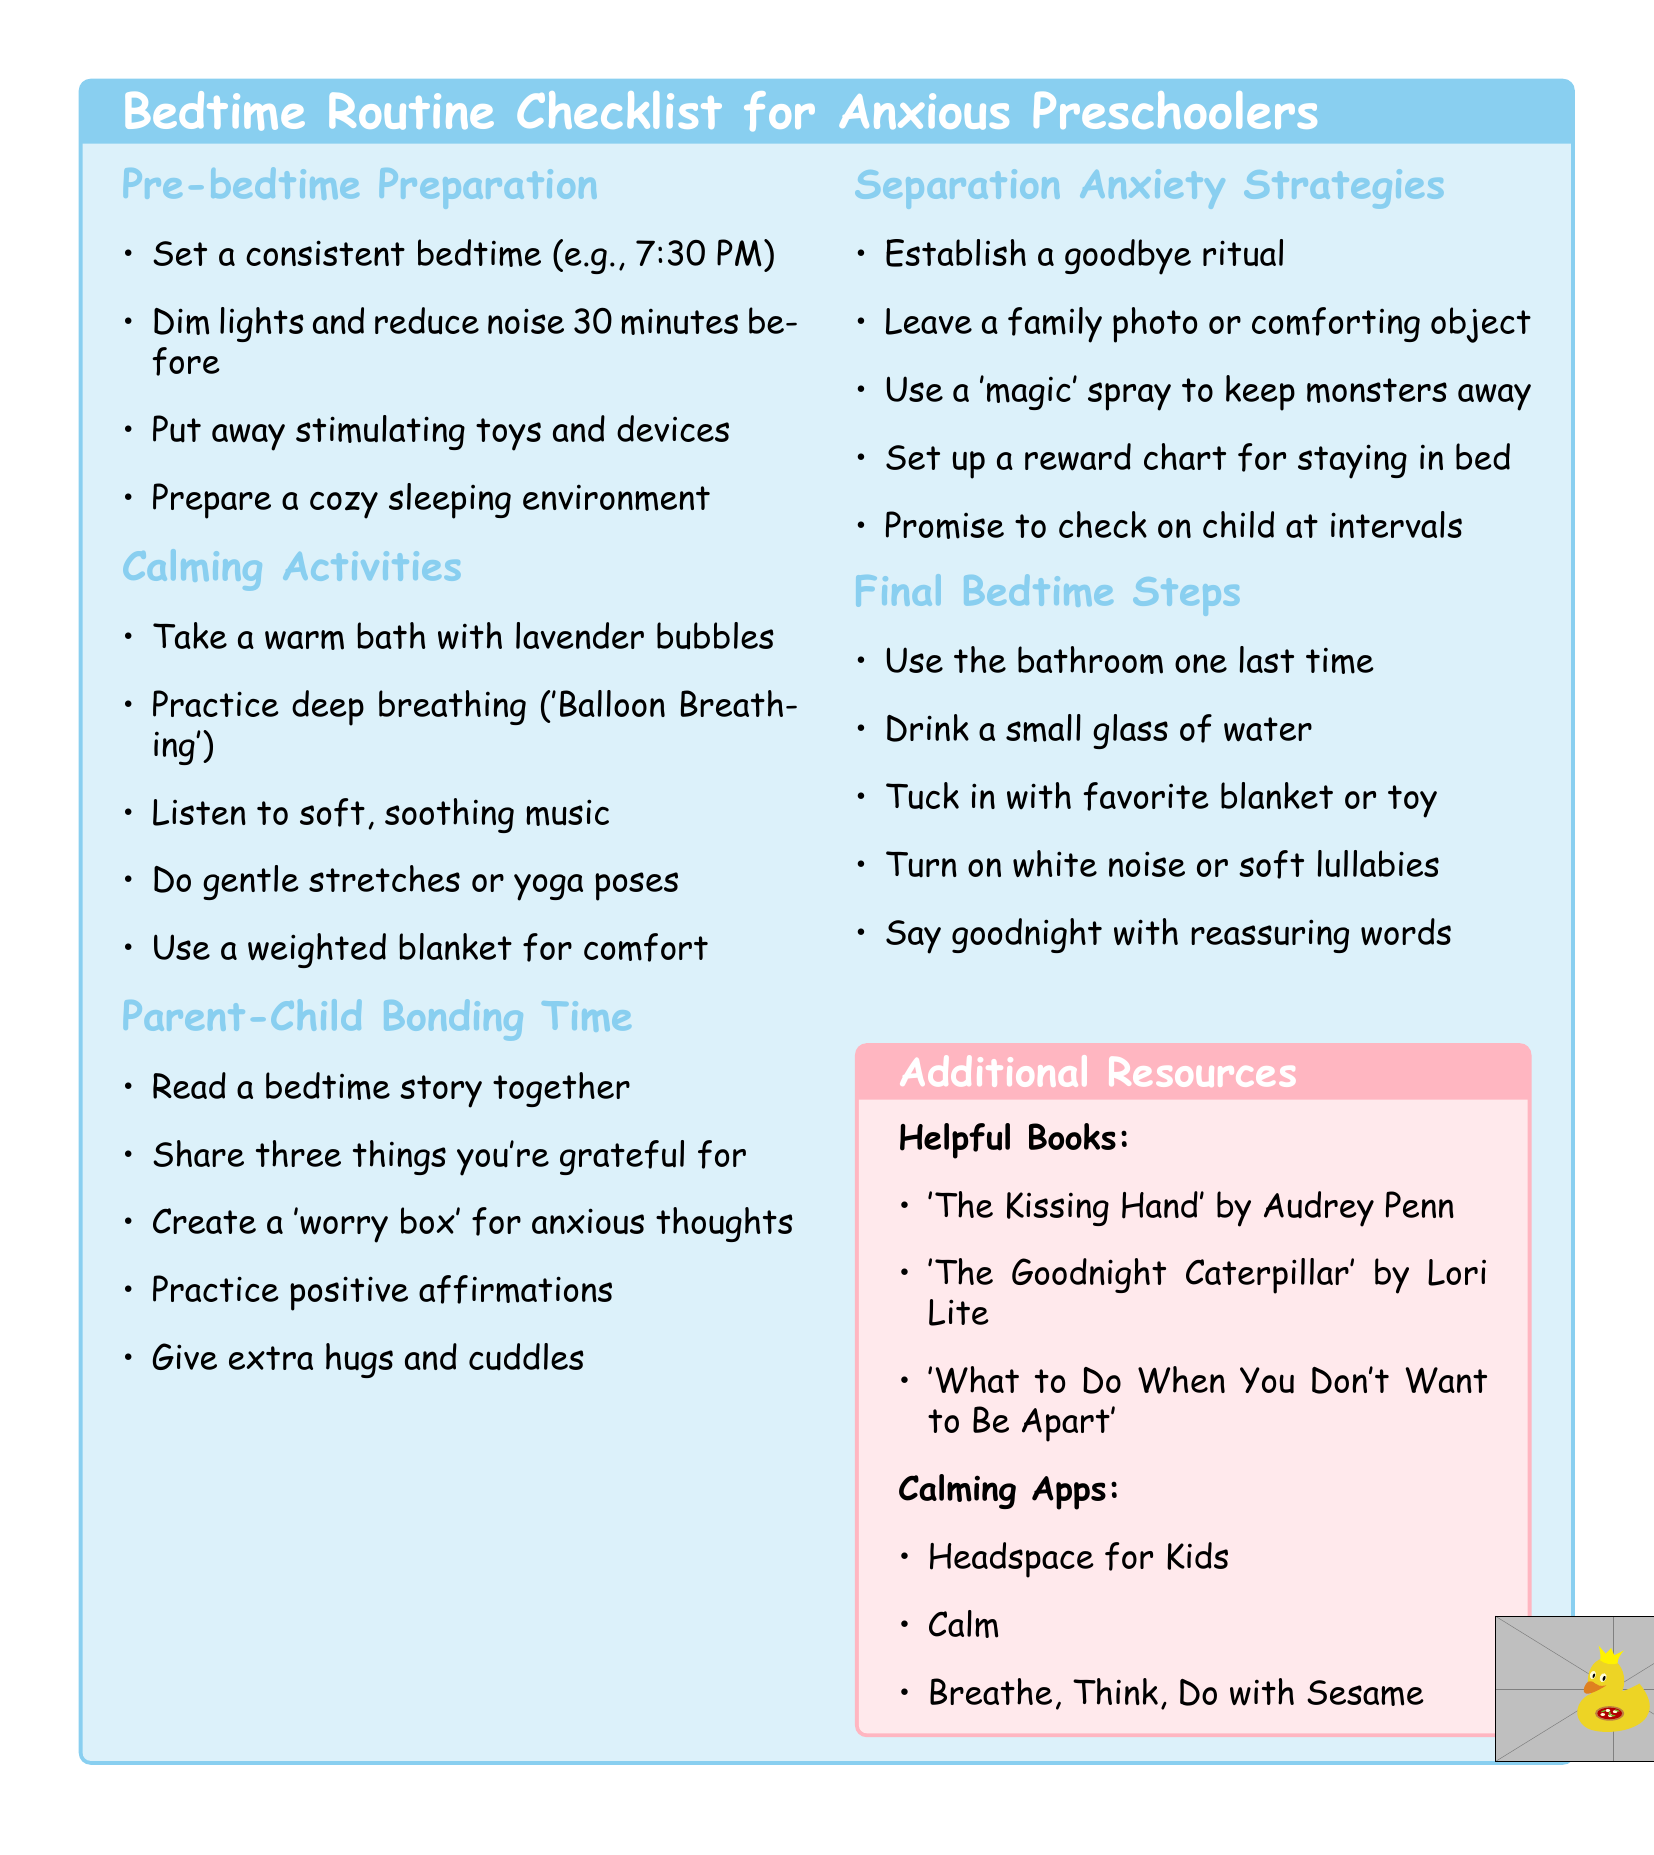What is the first item in Pre-bedtime Preparation? The first item listed under Pre-bedtime Preparation is the consistent bedtime.
Answer: Set a consistent bedtime (e.g., 7:30 PM) How many calming activities are suggested? The total number of calming activities in the document can be counted from the list.
Answer: Five What is one of the books listed in Helpful Books? The document lists specific books in the Helpful Books section, which can be directly cited.
Answer: 'The Kissing Hand' by Audrey Penn What is a suggested Parent-Child Bonding Time activity? The document provides specific activities for bonding time between parent and child.
Answer: Read a bedtime story together What should parents do to help with separation anxiety? The document lists specific strategies to combat separation anxiety.
Answer: Establish a goodbye ritual What calming app is mentioned? The document includes the names of specific calming apps.
Answer: Headspace for Kids What color is the background of the additional resources section? The color of the background can be determined from the document's description of this section.
Answer: Soft pink How many final bedtime steps are included? The document enumerates the final steps before bedtime, allowing for easy counting.
Answer: Five 